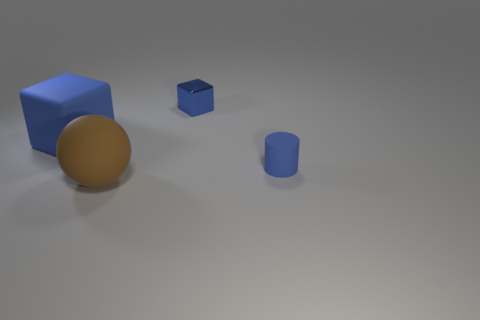Subtract all blue cubes. How many were subtracted if there are1blue cubes left? 1 Add 3 big blue matte blocks. How many objects exist? 7 Subtract 1 cylinders. How many cylinders are left? 0 Subtract all large blue rubber blocks. Subtract all shiny blocks. How many objects are left? 2 Add 3 small blue cubes. How many small blue cubes are left? 4 Add 4 spheres. How many spheres exist? 5 Subtract 1 blue cylinders. How many objects are left? 3 Subtract all balls. How many objects are left? 3 Subtract all brown cubes. Subtract all gray cylinders. How many cubes are left? 2 Subtract all blue blocks. How many red spheres are left? 0 